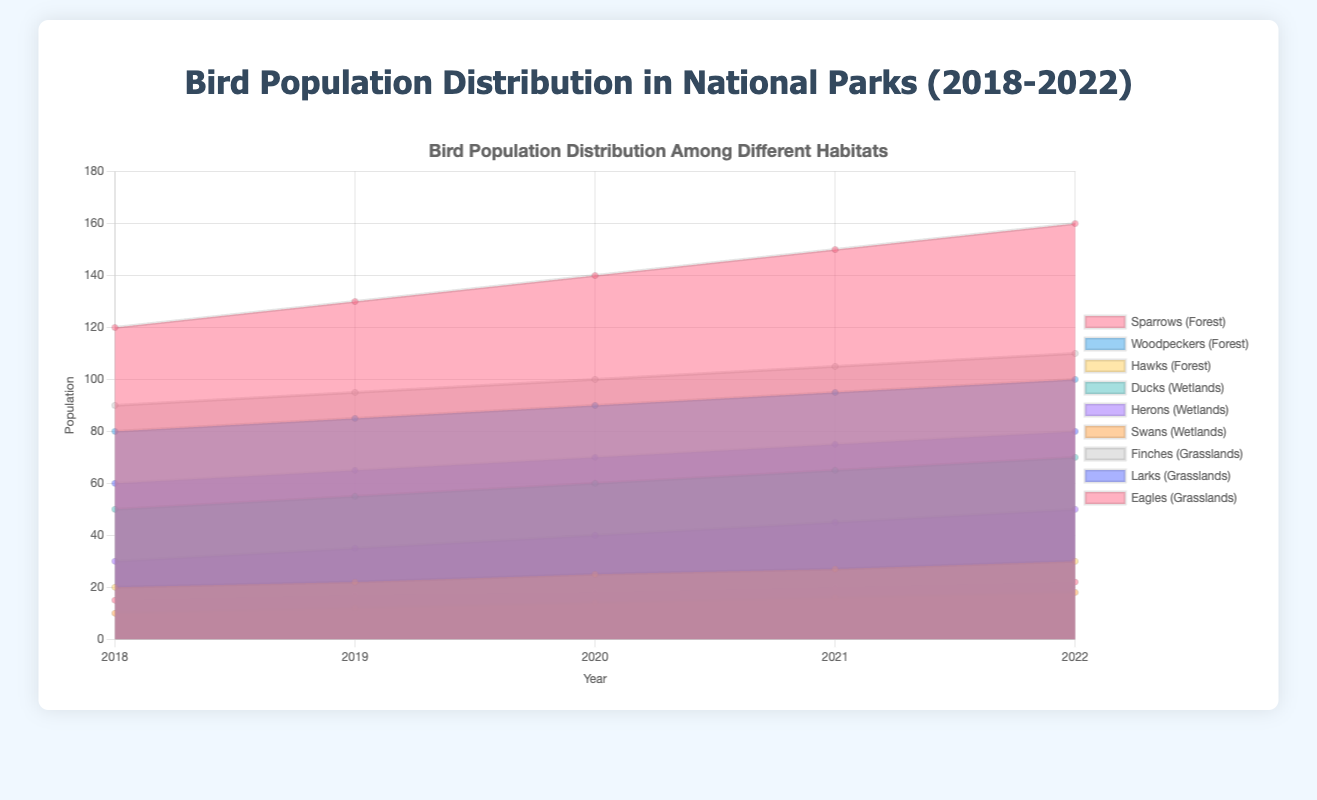What's the title of the chart? The title of the chart is written at the top and it's centered. We can read it directly from the top of the figure.
Answer: Bird Population Distribution in National Parks (2018-2022) What is the population of Sparrows in the Forest habitat in 2018? To find this information, locate the year 2018 on the x-axis and look at the segment representing Sparrows in the Forest habitat. Check the value on the y-axis where the segment reaches.
Answer: 120 How has the population of Ducks in Wetlands changed from 2018 to 2022? First, find the population values for Ducks in Wetlands for each year: 2018 (50), 2019 (55), 2020 (60), 2021 (65), and 2022 (70). Compare these values to see the change.
Answer: Increased by 20 Which habitat has the highest population of birds in 2022? Check the sum of all bird populations for each habitat in 2022. Forest (160 + 100 + 30 = 290), Wetlands (70 + 50 + 18 = 138), Grasslands (110 + 80 + 22 = 212). Forest has the highest total population.
Answer: Forest What is the overall trend for the population of Woodpeckers in Forest from 2018 to 2022? Identify the population numbers of Woodpeckers in Forest for each year and observe the trend: 2018 (80), 2019 (85), 2020 (90), 2021 (95), 2022 (100). The population consistently increases.
Answer: Increasing By how much did the population of Eagles in Grasslands increase from 2019 to 2022? Find the population of Eagles in Grasslands for 2019 (17) and 2022 (22). Subtract the population in 2019 from the population in 2022 to get the increase (22 - 17).
Answer: 5 What are the three bird species with the lowest populations in 2022, and in which habitats are they found? Look for the bird populations in 2022 and identify the three lowest values: Ducks (70), Herons (50), Swans (18). These species are all found in the Wetlands habitat.
Answer: Ducks, Herons, Swans in Wetlands Which bird species in the Wetlands habitat showed the highest increase in population from 2018 to 2022? Calculate the difference in population from 2018 to 2022 for each species in the Wetlands. Ducks: 70 - 50 = 20. Herons: 50 - 30 = 20. Swans: 18 - 10 = 8. Ducks and Herons both showed the highest increase.
Answer: Ducks, Herons Is the increase in Sparrows' population in Forest linear from 2018 to 2022? To determine linearity, check the year-by-year increases. Sparrows: 120 (2018), 130 (2019), 140 (2020), 150 (2021), 160 (2022). Each increase is consistently by 10, indicating a linear trend.
Answer: Yes, linear What is the total bird population in Grasslands in 2021? Sum the populations of all bird species in Grasslands for the year 2021: Finches (105) + Larks (75) + Eagles (20). Total population = 105 + 75 + 20.
Answer: 200 